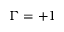Convert formula to latex. <formula><loc_0><loc_0><loc_500><loc_500>\Gamma = + 1</formula> 